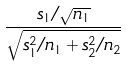Convert formula to latex. <formula><loc_0><loc_0><loc_500><loc_500>\frac { s _ { 1 } / \sqrt { n _ { 1 } } } { \sqrt { s _ { 1 } ^ { 2 } / n _ { 1 } + s _ { 2 } ^ { 2 } / n _ { 2 } } }</formula> 